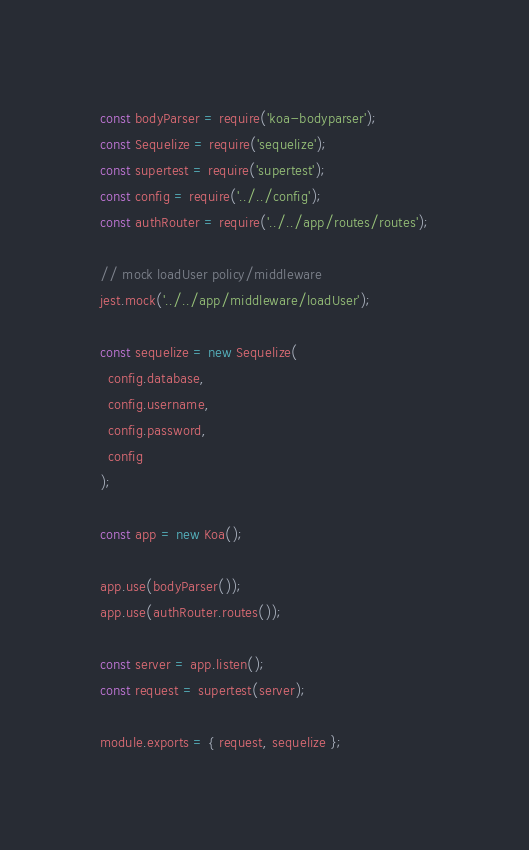Convert code to text. <code><loc_0><loc_0><loc_500><loc_500><_JavaScript_>const bodyParser = require('koa-bodyparser');
const Sequelize = require('sequelize');
const supertest = require('supertest');
const config = require('../../config');
const authRouter = require('../../app/routes/routes');

// mock loadUser policy/middleware
jest.mock('../../app/middleware/loadUser');

const sequelize = new Sequelize(
  config.database,
  config.username,
  config.password,
  config
);

const app = new Koa();

app.use(bodyParser());
app.use(authRouter.routes());

const server = app.listen();
const request = supertest(server);

module.exports = { request, sequelize };
</code> 